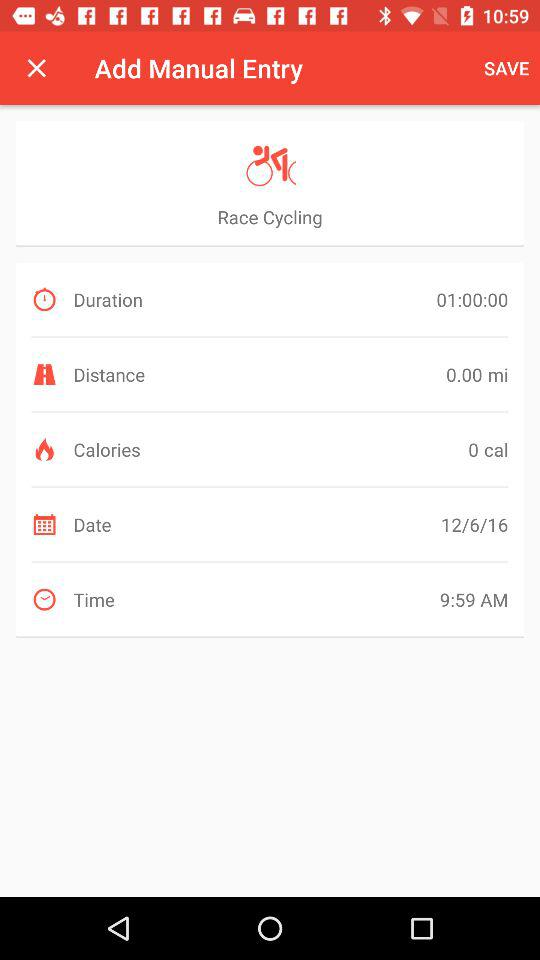What is the mentioned time? The mentioned time is 9:59 AM. 